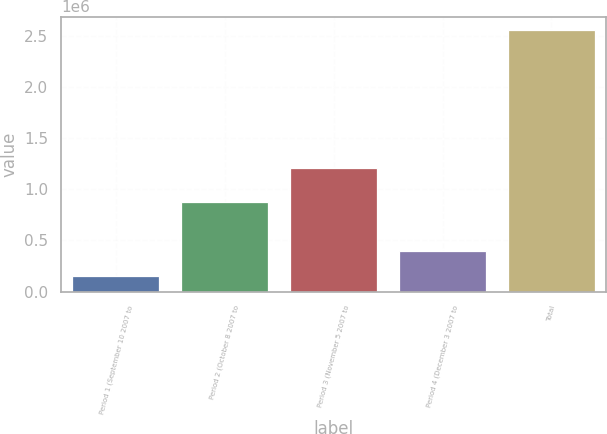<chart> <loc_0><loc_0><loc_500><loc_500><bar_chart><fcel>Period 1 (September 10 2007 to<fcel>Period 2 (October 8 2007 to<fcel>Period 3 (November 5 2007 to<fcel>Period 4 (December 3 2007 to<fcel>Total<nl><fcel>153500<fcel>879350<fcel>1.2111e+06<fcel>394285<fcel>2.56135e+06<nl></chart> 